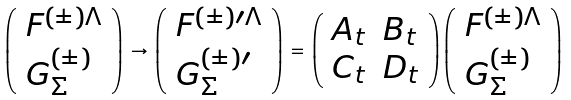Convert formula to latex. <formula><loc_0><loc_0><loc_500><loc_500>\left ( \begin{array} { l } { { F ^ { ( \pm ) \Lambda } } } \\ { { G _ { \Sigma } ^ { ( \pm ) } } } \end{array} \right ) \, \rightarrow \, \left ( \begin{array} { l } { { F ^ { ( \pm ) \prime \Lambda } } } \\ { { G _ { \Sigma } ^ { ( \pm ) \prime } } } \end{array} \right ) \, = \, \left ( \begin{array} { l l } { { A _ { t } } } & { { B _ { t } } } \\ { { C _ { t } } } & { { D _ { t } } } \end{array} \right ) \left ( \begin{array} { l } { { F ^ { ( \pm ) \Lambda } } } \\ { { G _ { \Sigma } ^ { ( \pm ) } } } \end{array} \right )</formula> 